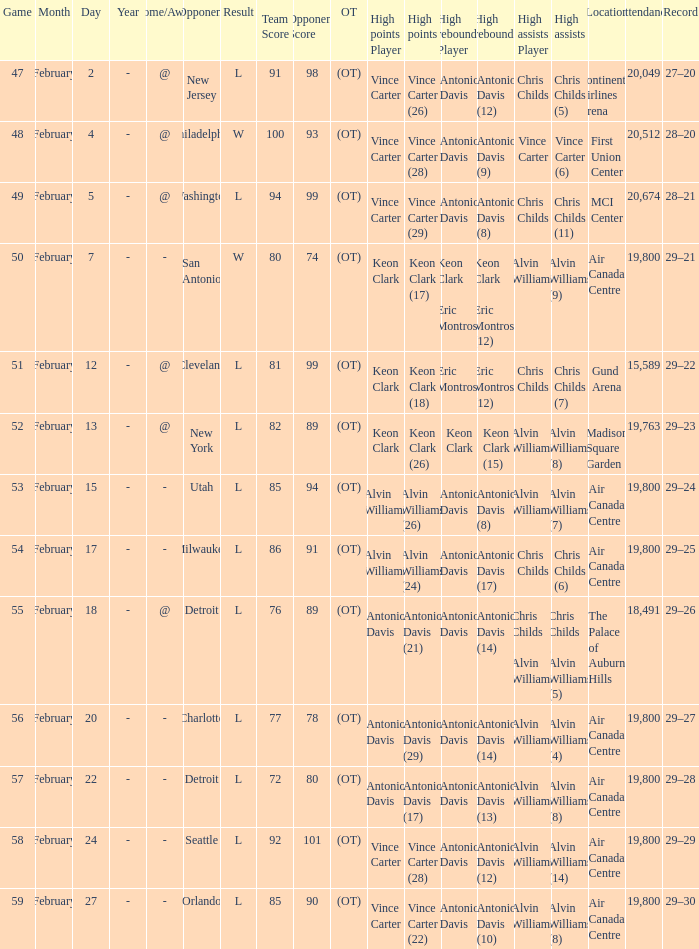What is the Record when the high rebounds was Antonio Davis (9)? 28–20. 